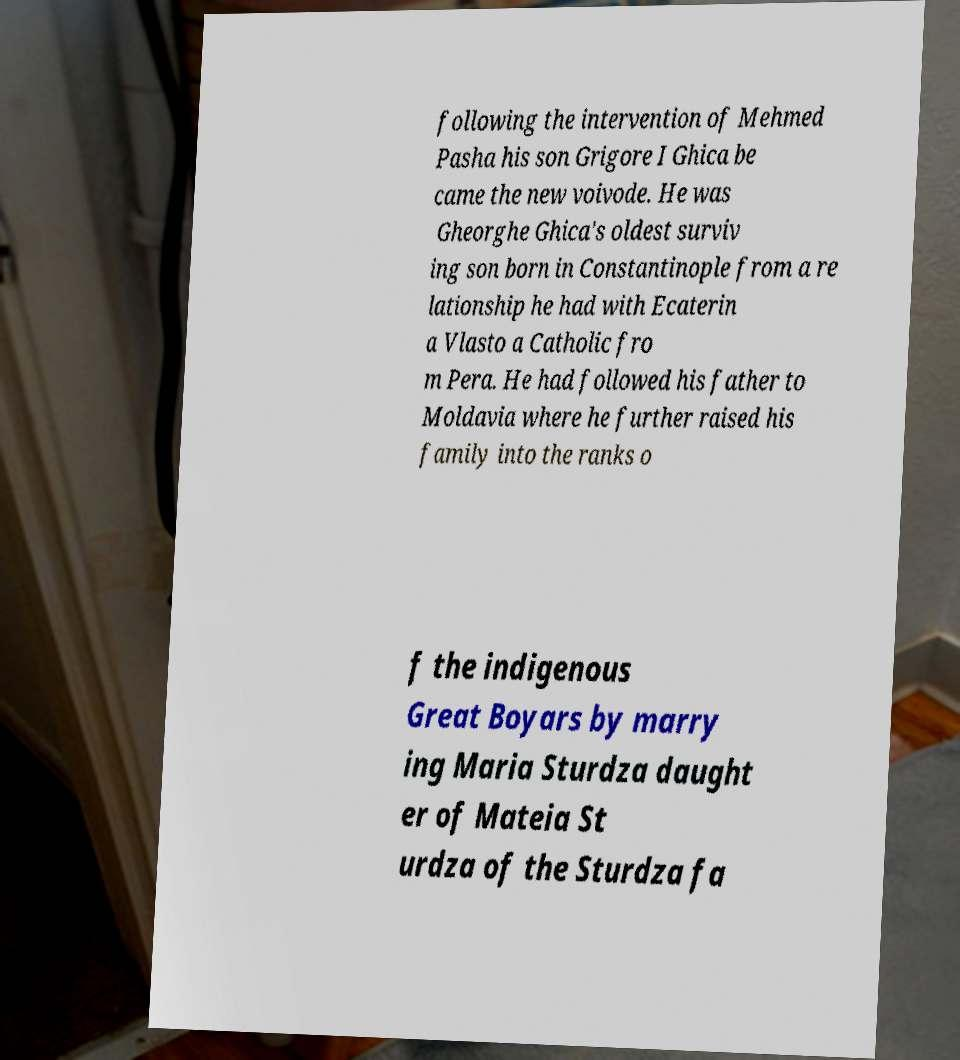Please identify and transcribe the text found in this image. following the intervention of Mehmed Pasha his son Grigore I Ghica be came the new voivode. He was Gheorghe Ghica's oldest surviv ing son born in Constantinople from a re lationship he had with Ecaterin a Vlasto a Catholic fro m Pera. He had followed his father to Moldavia where he further raised his family into the ranks o f the indigenous Great Boyars by marry ing Maria Sturdza daught er of Mateia St urdza of the Sturdza fa 